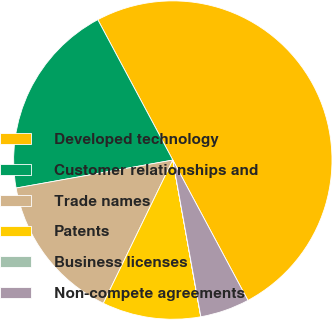<chart> <loc_0><loc_0><loc_500><loc_500><pie_chart><fcel>Developed technology<fcel>Customer relationships and<fcel>Trade names<fcel>Patents<fcel>Business licenses<fcel>Non-compete agreements<nl><fcel>49.99%<fcel>20.0%<fcel>15.0%<fcel>10.0%<fcel>0.01%<fcel>5.0%<nl></chart> 